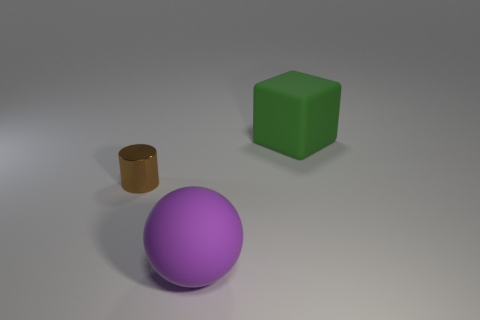Add 3 big green rubber blocks. How many objects exist? 6 Subtract all cylinders. How many objects are left? 2 Subtract all tiny yellow metallic balls. Subtract all large green rubber cubes. How many objects are left? 2 Add 1 tiny brown metal cylinders. How many tiny brown metal cylinders are left? 2 Add 2 purple spheres. How many purple spheres exist? 3 Subtract 0 yellow cylinders. How many objects are left? 3 